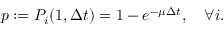Convert formula to latex. <formula><loc_0><loc_0><loc_500><loc_500>p \colon = P _ { i } ( 1 , \Delta t ) = 1 - e ^ { - \mu \Delta t } , \quad \forall i .</formula> 